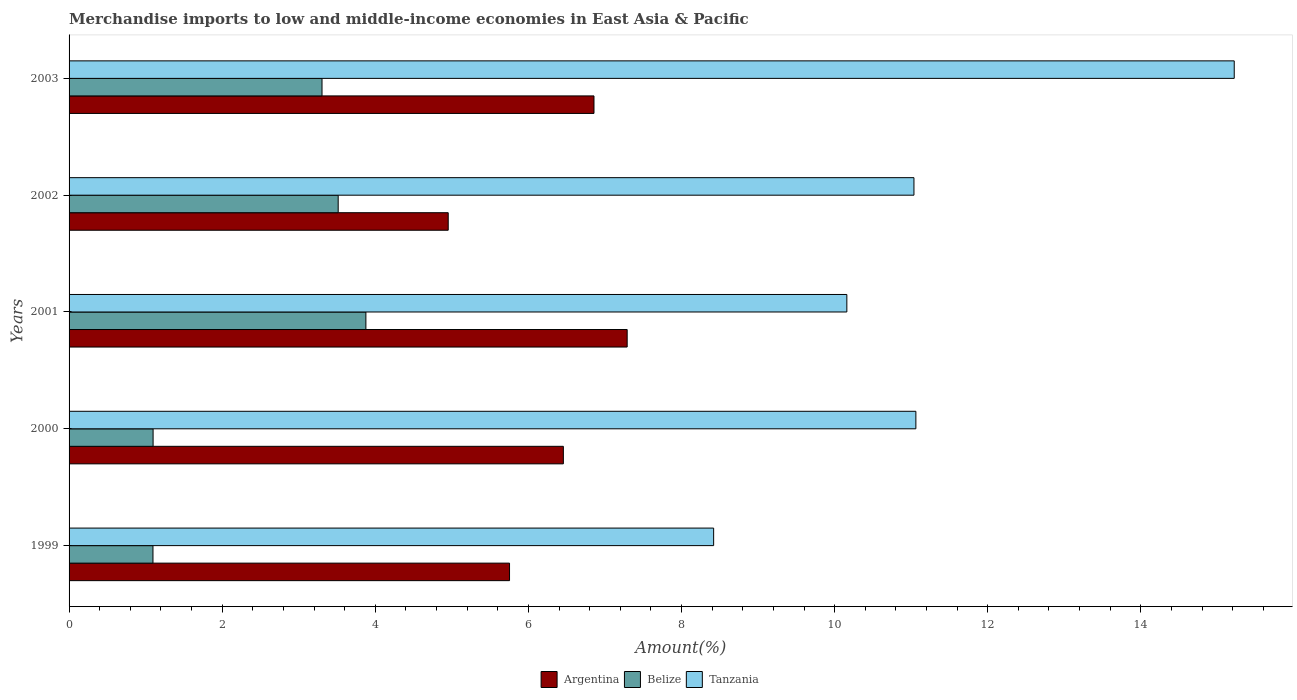How many different coloured bars are there?
Give a very brief answer. 3. How many groups of bars are there?
Provide a short and direct response. 5. How many bars are there on the 1st tick from the top?
Provide a succinct answer. 3. In how many cases, is the number of bars for a given year not equal to the number of legend labels?
Your response must be concise. 0. What is the percentage of amount earned from merchandise imports in Tanzania in 2000?
Make the answer very short. 11.06. Across all years, what is the maximum percentage of amount earned from merchandise imports in Tanzania?
Your response must be concise. 15.22. Across all years, what is the minimum percentage of amount earned from merchandise imports in Argentina?
Ensure brevity in your answer.  4.95. What is the total percentage of amount earned from merchandise imports in Tanzania in the graph?
Make the answer very short. 55.9. What is the difference between the percentage of amount earned from merchandise imports in Tanzania in 2000 and that in 2003?
Offer a terse response. -4.16. What is the difference between the percentage of amount earned from merchandise imports in Belize in 2001 and the percentage of amount earned from merchandise imports in Tanzania in 1999?
Your response must be concise. -4.54. What is the average percentage of amount earned from merchandise imports in Tanzania per year?
Give a very brief answer. 11.18. In the year 2003, what is the difference between the percentage of amount earned from merchandise imports in Tanzania and percentage of amount earned from merchandise imports in Belize?
Make the answer very short. 11.92. What is the ratio of the percentage of amount earned from merchandise imports in Tanzania in 2002 to that in 2003?
Make the answer very short. 0.73. What is the difference between the highest and the second highest percentage of amount earned from merchandise imports in Belize?
Make the answer very short. 0.36. What is the difference between the highest and the lowest percentage of amount earned from merchandise imports in Belize?
Offer a terse response. 2.78. Is the sum of the percentage of amount earned from merchandise imports in Belize in 2002 and 2003 greater than the maximum percentage of amount earned from merchandise imports in Argentina across all years?
Offer a terse response. No. What does the 2nd bar from the top in 1999 represents?
Make the answer very short. Belize. What does the 3rd bar from the bottom in 2002 represents?
Ensure brevity in your answer.  Tanzania. Is it the case that in every year, the sum of the percentage of amount earned from merchandise imports in Argentina and percentage of amount earned from merchandise imports in Belize is greater than the percentage of amount earned from merchandise imports in Tanzania?
Your answer should be very brief. No. Are all the bars in the graph horizontal?
Keep it short and to the point. Yes. Are the values on the major ticks of X-axis written in scientific E-notation?
Offer a terse response. No. How are the legend labels stacked?
Provide a short and direct response. Horizontal. What is the title of the graph?
Your answer should be compact. Merchandise imports to low and middle-income economies in East Asia & Pacific. Does "Thailand" appear as one of the legend labels in the graph?
Give a very brief answer. No. What is the label or title of the X-axis?
Ensure brevity in your answer.  Amount(%). What is the label or title of the Y-axis?
Your answer should be compact. Years. What is the Amount(%) of Argentina in 1999?
Provide a short and direct response. 5.75. What is the Amount(%) of Belize in 1999?
Offer a very short reply. 1.1. What is the Amount(%) in Tanzania in 1999?
Your answer should be very brief. 8.42. What is the Amount(%) of Argentina in 2000?
Make the answer very short. 6.46. What is the Amount(%) in Belize in 2000?
Make the answer very short. 1.1. What is the Amount(%) of Tanzania in 2000?
Make the answer very short. 11.06. What is the Amount(%) in Argentina in 2001?
Provide a short and direct response. 7.29. What is the Amount(%) of Belize in 2001?
Ensure brevity in your answer.  3.88. What is the Amount(%) of Tanzania in 2001?
Provide a short and direct response. 10.16. What is the Amount(%) in Argentina in 2002?
Provide a short and direct response. 4.95. What is the Amount(%) in Belize in 2002?
Keep it short and to the point. 3.52. What is the Amount(%) of Tanzania in 2002?
Offer a very short reply. 11.04. What is the Amount(%) in Argentina in 2003?
Your answer should be compact. 6.86. What is the Amount(%) of Belize in 2003?
Provide a short and direct response. 3.3. What is the Amount(%) in Tanzania in 2003?
Give a very brief answer. 15.22. Across all years, what is the maximum Amount(%) in Argentina?
Your response must be concise. 7.29. Across all years, what is the maximum Amount(%) of Belize?
Provide a succinct answer. 3.88. Across all years, what is the maximum Amount(%) in Tanzania?
Your answer should be compact. 15.22. Across all years, what is the minimum Amount(%) of Argentina?
Offer a very short reply. 4.95. Across all years, what is the minimum Amount(%) in Belize?
Keep it short and to the point. 1.1. Across all years, what is the minimum Amount(%) of Tanzania?
Make the answer very short. 8.42. What is the total Amount(%) in Argentina in the graph?
Provide a short and direct response. 31.31. What is the total Amount(%) of Belize in the graph?
Keep it short and to the point. 12.89. What is the total Amount(%) of Tanzania in the graph?
Your answer should be very brief. 55.9. What is the difference between the Amount(%) in Argentina in 1999 and that in 2000?
Your answer should be compact. -0.7. What is the difference between the Amount(%) of Belize in 1999 and that in 2000?
Ensure brevity in your answer.  -0. What is the difference between the Amount(%) in Tanzania in 1999 and that in 2000?
Ensure brevity in your answer.  -2.64. What is the difference between the Amount(%) of Argentina in 1999 and that in 2001?
Give a very brief answer. -1.54. What is the difference between the Amount(%) of Belize in 1999 and that in 2001?
Offer a very short reply. -2.78. What is the difference between the Amount(%) of Tanzania in 1999 and that in 2001?
Offer a terse response. -1.74. What is the difference between the Amount(%) of Argentina in 1999 and that in 2002?
Give a very brief answer. 0.8. What is the difference between the Amount(%) of Belize in 1999 and that in 2002?
Your answer should be very brief. -2.42. What is the difference between the Amount(%) in Tanzania in 1999 and that in 2002?
Your response must be concise. -2.62. What is the difference between the Amount(%) of Argentina in 1999 and that in 2003?
Provide a succinct answer. -1.1. What is the difference between the Amount(%) in Belize in 1999 and that in 2003?
Ensure brevity in your answer.  -2.21. What is the difference between the Amount(%) of Tanzania in 1999 and that in 2003?
Your answer should be very brief. -6.8. What is the difference between the Amount(%) of Argentina in 2000 and that in 2001?
Offer a very short reply. -0.83. What is the difference between the Amount(%) in Belize in 2000 and that in 2001?
Offer a very short reply. -2.78. What is the difference between the Amount(%) of Tanzania in 2000 and that in 2001?
Make the answer very short. 0.9. What is the difference between the Amount(%) in Argentina in 2000 and that in 2002?
Give a very brief answer. 1.5. What is the difference between the Amount(%) of Belize in 2000 and that in 2002?
Give a very brief answer. -2.42. What is the difference between the Amount(%) in Tanzania in 2000 and that in 2002?
Offer a very short reply. 0.03. What is the difference between the Amount(%) of Argentina in 2000 and that in 2003?
Your response must be concise. -0.4. What is the difference between the Amount(%) of Belize in 2000 and that in 2003?
Your answer should be compact. -2.21. What is the difference between the Amount(%) in Tanzania in 2000 and that in 2003?
Offer a very short reply. -4.16. What is the difference between the Amount(%) in Argentina in 2001 and that in 2002?
Offer a terse response. 2.34. What is the difference between the Amount(%) of Belize in 2001 and that in 2002?
Provide a succinct answer. 0.36. What is the difference between the Amount(%) in Tanzania in 2001 and that in 2002?
Your response must be concise. -0.88. What is the difference between the Amount(%) of Argentina in 2001 and that in 2003?
Your answer should be compact. 0.43. What is the difference between the Amount(%) in Belize in 2001 and that in 2003?
Your answer should be very brief. 0.57. What is the difference between the Amount(%) of Tanzania in 2001 and that in 2003?
Ensure brevity in your answer.  -5.06. What is the difference between the Amount(%) in Argentina in 2002 and that in 2003?
Your answer should be compact. -1.9. What is the difference between the Amount(%) of Belize in 2002 and that in 2003?
Provide a succinct answer. 0.21. What is the difference between the Amount(%) of Tanzania in 2002 and that in 2003?
Offer a terse response. -4.18. What is the difference between the Amount(%) of Argentina in 1999 and the Amount(%) of Belize in 2000?
Give a very brief answer. 4.66. What is the difference between the Amount(%) of Argentina in 1999 and the Amount(%) of Tanzania in 2000?
Ensure brevity in your answer.  -5.31. What is the difference between the Amount(%) of Belize in 1999 and the Amount(%) of Tanzania in 2000?
Your response must be concise. -9.97. What is the difference between the Amount(%) in Argentina in 1999 and the Amount(%) in Belize in 2001?
Provide a short and direct response. 1.88. What is the difference between the Amount(%) of Argentina in 1999 and the Amount(%) of Tanzania in 2001?
Your response must be concise. -4.41. What is the difference between the Amount(%) of Belize in 1999 and the Amount(%) of Tanzania in 2001?
Provide a succinct answer. -9.06. What is the difference between the Amount(%) in Argentina in 1999 and the Amount(%) in Belize in 2002?
Your answer should be very brief. 2.24. What is the difference between the Amount(%) of Argentina in 1999 and the Amount(%) of Tanzania in 2002?
Your response must be concise. -5.28. What is the difference between the Amount(%) of Belize in 1999 and the Amount(%) of Tanzania in 2002?
Give a very brief answer. -9.94. What is the difference between the Amount(%) of Argentina in 1999 and the Amount(%) of Belize in 2003?
Make the answer very short. 2.45. What is the difference between the Amount(%) of Argentina in 1999 and the Amount(%) of Tanzania in 2003?
Offer a very short reply. -9.47. What is the difference between the Amount(%) in Belize in 1999 and the Amount(%) in Tanzania in 2003?
Provide a succinct answer. -14.12. What is the difference between the Amount(%) in Argentina in 2000 and the Amount(%) in Belize in 2001?
Keep it short and to the point. 2.58. What is the difference between the Amount(%) in Argentina in 2000 and the Amount(%) in Tanzania in 2001?
Keep it short and to the point. -3.7. What is the difference between the Amount(%) of Belize in 2000 and the Amount(%) of Tanzania in 2001?
Make the answer very short. -9.06. What is the difference between the Amount(%) in Argentina in 2000 and the Amount(%) in Belize in 2002?
Your answer should be compact. 2.94. What is the difference between the Amount(%) of Argentina in 2000 and the Amount(%) of Tanzania in 2002?
Your response must be concise. -4.58. What is the difference between the Amount(%) in Belize in 2000 and the Amount(%) in Tanzania in 2002?
Offer a very short reply. -9.94. What is the difference between the Amount(%) of Argentina in 2000 and the Amount(%) of Belize in 2003?
Provide a succinct answer. 3.15. What is the difference between the Amount(%) of Argentina in 2000 and the Amount(%) of Tanzania in 2003?
Offer a very short reply. -8.76. What is the difference between the Amount(%) of Belize in 2000 and the Amount(%) of Tanzania in 2003?
Your answer should be very brief. -14.12. What is the difference between the Amount(%) in Argentina in 2001 and the Amount(%) in Belize in 2002?
Your response must be concise. 3.77. What is the difference between the Amount(%) in Argentina in 2001 and the Amount(%) in Tanzania in 2002?
Your answer should be very brief. -3.75. What is the difference between the Amount(%) of Belize in 2001 and the Amount(%) of Tanzania in 2002?
Make the answer very short. -7.16. What is the difference between the Amount(%) of Argentina in 2001 and the Amount(%) of Belize in 2003?
Your answer should be compact. 3.99. What is the difference between the Amount(%) of Argentina in 2001 and the Amount(%) of Tanzania in 2003?
Offer a very short reply. -7.93. What is the difference between the Amount(%) of Belize in 2001 and the Amount(%) of Tanzania in 2003?
Your response must be concise. -11.34. What is the difference between the Amount(%) of Argentina in 2002 and the Amount(%) of Belize in 2003?
Your answer should be compact. 1.65. What is the difference between the Amount(%) in Argentina in 2002 and the Amount(%) in Tanzania in 2003?
Offer a terse response. -10.27. What is the difference between the Amount(%) in Belize in 2002 and the Amount(%) in Tanzania in 2003?
Make the answer very short. -11.7. What is the average Amount(%) of Argentina per year?
Keep it short and to the point. 6.26. What is the average Amount(%) in Belize per year?
Give a very brief answer. 2.58. What is the average Amount(%) of Tanzania per year?
Offer a terse response. 11.18. In the year 1999, what is the difference between the Amount(%) in Argentina and Amount(%) in Belize?
Offer a terse response. 4.66. In the year 1999, what is the difference between the Amount(%) of Argentina and Amount(%) of Tanzania?
Provide a succinct answer. -2.67. In the year 1999, what is the difference between the Amount(%) of Belize and Amount(%) of Tanzania?
Keep it short and to the point. -7.32. In the year 2000, what is the difference between the Amount(%) of Argentina and Amount(%) of Belize?
Your answer should be compact. 5.36. In the year 2000, what is the difference between the Amount(%) of Argentina and Amount(%) of Tanzania?
Keep it short and to the point. -4.6. In the year 2000, what is the difference between the Amount(%) in Belize and Amount(%) in Tanzania?
Your response must be concise. -9.96. In the year 2001, what is the difference between the Amount(%) of Argentina and Amount(%) of Belize?
Ensure brevity in your answer.  3.41. In the year 2001, what is the difference between the Amount(%) of Argentina and Amount(%) of Tanzania?
Your answer should be compact. -2.87. In the year 2001, what is the difference between the Amount(%) of Belize and Amount(%) of Tanzania?
Provide a succinct answer. -6.28. In the year 2002, what is the difference between the Amount(%) of Argentina and Amount(%) of Belize?
Offer a very short reply. 1.44. In the year 2002, what is the difference between the Amount(%) in Argentina and Amount(%) in Tanzania?
Ensure brevity in your answer.  -6.08. In the year 2002, what is the difference between the Amount(%) of Belize and Amount(%) of Tanzania?
Your response must be concise. -7.52. In the year 2003, what is the difference between the Amount(%) in Argentina and Amount(%) in Belize?
Offer a terse response. 3.55. In the year 2003, what is the difference between the Amount(%) in Argentina and Amount(%) in Tanzania?
Ensure brevity in your answer.  -8.36. In the year 2003, what is the difference between the Amount(%) of Belize and Amount(%) of Tanzania?
Your answer should be compact. -11.92. What is the ratio of the Amount(%) in Argentina in 1999 to that in 2000?
Offer a terse response. 0.89. What is the ratio of the Amount(%) of Belize in 1999 to that in 2000?
Your answer should be compact. 1. What is the ratio of the Amount(%) in Tanzania in 1999 to that in 2000?
Give a very brief answer. 0.76. What is the ratio of the Amount(%) in Argentina in 1999 to that in 2001?
Offer a very short reply. 0.79. What is the ratio of the Amount(%) of Belize in 1999 to that in 2001?
Provide a short and direct response. 0.28. What is the ratio of the Amount(%) of Tanzania in 1999 to that in 2001?
Keep it short and to the point. 0.83. What is the ratio of the Amount(%) of Argentina in 1999 to that in 2002?
Keep it short and to the point. 1.16. What is the ratio of the Amount(%) of Belize in 1999 to that in 2002?
Keep it short and to the point. 0.31. What is the ratio of the Amount(%) in Tanzania in 1999 to that in 2002?
Provide a short and direct response. 0.76. What is the ratio of the Amount(%) in Argentina in 1999 to that in 2003?
Offer a terse response. 0.84. What is the ratio of the Amount(%) in Belize in 1999 to that in 2003?
Provide a short and direct response. 0.33. What is the ratio of the Amount(%) in Tanzania in 1999 to that in 2003?
Ensure brevity in your answer.  0.55. What is the ratio of the Amount(%) of Argentina in 2000 to that in 2001?
Your answer should be compact. 0.89. What is the ratio of the Amount(%) in Belize in 2000 to that in 2001?
Give a very brief answer. 0.28. What is the ratio of the Amount(%) of Tanzania in 2000 to that in 2001?
Make the answer very short. 1.09. What is the ratio of the Amount(%) of Argentina in 2000 to that in 2002?
Your answer should be very brief. 1.3. What is the ratio of the Amount(%) in Belize in 2000 to that in 2002?
Ensure brevity in your answer.  0.31. What is the ratio of the Amount(%) in Tanzania in 2000 to that in 2002?
Offer a terse response. 1. What is the ratio of the Amount(%) in Argentina in 2000 to that in 2003?
Make the answer very short. 0.94. What is the ratio of the Amount(%) in Belize in 2000 to that in 2003?
Keep it short and to the point. 0.33. What is the ratio of the Amount(%) in Tanzania in 2000 to that in 2003?
Offer a terse response. 0.73. What is the ratio of the Amount(%) in Argentina in 2001 to that in 2002?
Ensure brevity in your answer.  1.47. What is the ratio of the Amount(%) of Belize in 2001 to that in 2002?
Your response must be concise. 1.1. What is the ratio of the Amount(%) of Tanzania in 2001 to that in 2002?
Your answer should be very brief. 0.92. What is the ratio of the Amount(%) of Argentina in 2001 to that in 2003?
Ensure brevity in your answer.  1.06. What is the ratio of the Amount(%) in Belize in 2001 to that in 2003?
Offer a very short reply. 1.17. What is the ratio of the Amount(%) in Tanzania in 2001 to that in 2003?
Ensure brevity in your answer.  0.67. What is the ratio of the Amount(%) in Argentina in 2002 to that in 2003?
Make the answer very short. 0.72. What is the ratio of the Amount(%) of Belize in 2002 to that in 2003?
Your answer should be very brief. 1.06. What is the ratio of the Amount(%) of Tanzania in 2002 to that in 2003?
Your response must be concise. 0.73. What is the difference between the highest and the second highest Amount(%) in Argentina?
Give a very brief answer. 0.43. What is the difference between the highest and the second highest Amount(%) of Belize?
Give a very brief answer. 0.36. What is the difference between the highest and the second highest Amount(%) of Tanzania?
Offer a very short reply. 4.16. What is the difference between the highest and the lowest Amount(%) in Argentina?
Ensure brevity in your answer.  2.34. What is the difference between the highest and the lowest Amount(%) in Belize?
Your answer should be very brief. 2.78. What is the difference between the highest and the lowest Amount(%) in Tanzania?
Your response must be concise. 6.8. 